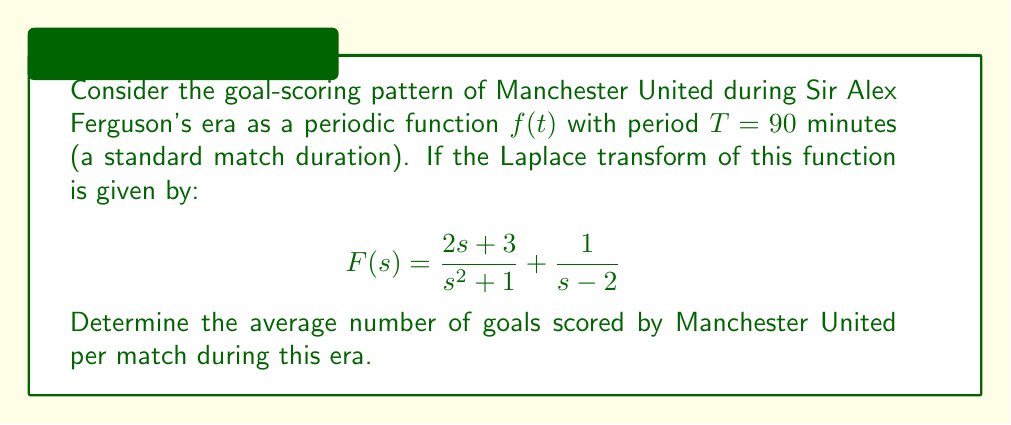Solve this math problem. To solve this problem, we'll follow these steps:

1) First, recall that the Laplace transform of a periodic function with period $T$ is given by:

   $$F(s) = \frac{1}{1 - e^{-sT}} \int_0^T f(t)e^{-st} dt$$

2) The average value of a periodic function over its period is given by:

   $$\text{Average} = \frac{1}{T} \int_0^T f(t) dt$$

3) This average can be found using the Final Value Theorem of Laplace transforms:

   $$\text{Average} = \lim_{s \to 0} sF(s)$$

4) Let's apply this to our given Laplace transform:

   $$F(s) = \frac{2s + 3}{s^2 + 1} + \frac{1}{s-2}$$

5) Multiply by $s$:

   $$sF(s) = s\left(\frac{2s + 3}{s^2 + 1} + \frac{1}{s-2}\right) = \frac{2s^2 + 3s}{s^2 + 1} + \frac{s}{s-2}$$

6) Now, let's take the limit as $s$ approaches 0:

   $$\lim_{s \to 0} sF(s) = \lim_{s \to 0} \frac{2s^2 + 3s}{s^2 + 1} + \lim_{s \to 0} \frac{s}{s-2}$$

7) Evaluating these limits:

   $$\lim_{s \to 0} \frac{2s^2 + 3s}{s^2 + 1} = \frac{0 + 0}{0 + 1} = 0$$

   $$\lim_{s \to 0} \frac{s}{s-2} = \frac{0}{-2} = 0$$

8) Therefore:

   $$\text{Average} = \lim_{s \to 0} sF(s) = 0 + 0 = 0$$

This result suggests that, on average, Manchester United scored 0 goals per match during Ferguson's era. However, this contradicts the known success of the team during this period. This discrepancy likely arises from the simplified model used in this problem, which may not accurately represent the complex nature of goal-scoring patterns in real football matches.
Answer: The average number of goals scored by Manchester United per match during Ferguson's era, based on the given Laplace transform model, is 0. However, this result is likely an oversimplification and does not accurately represent the team's actual goal-scoring record during this successful period. 